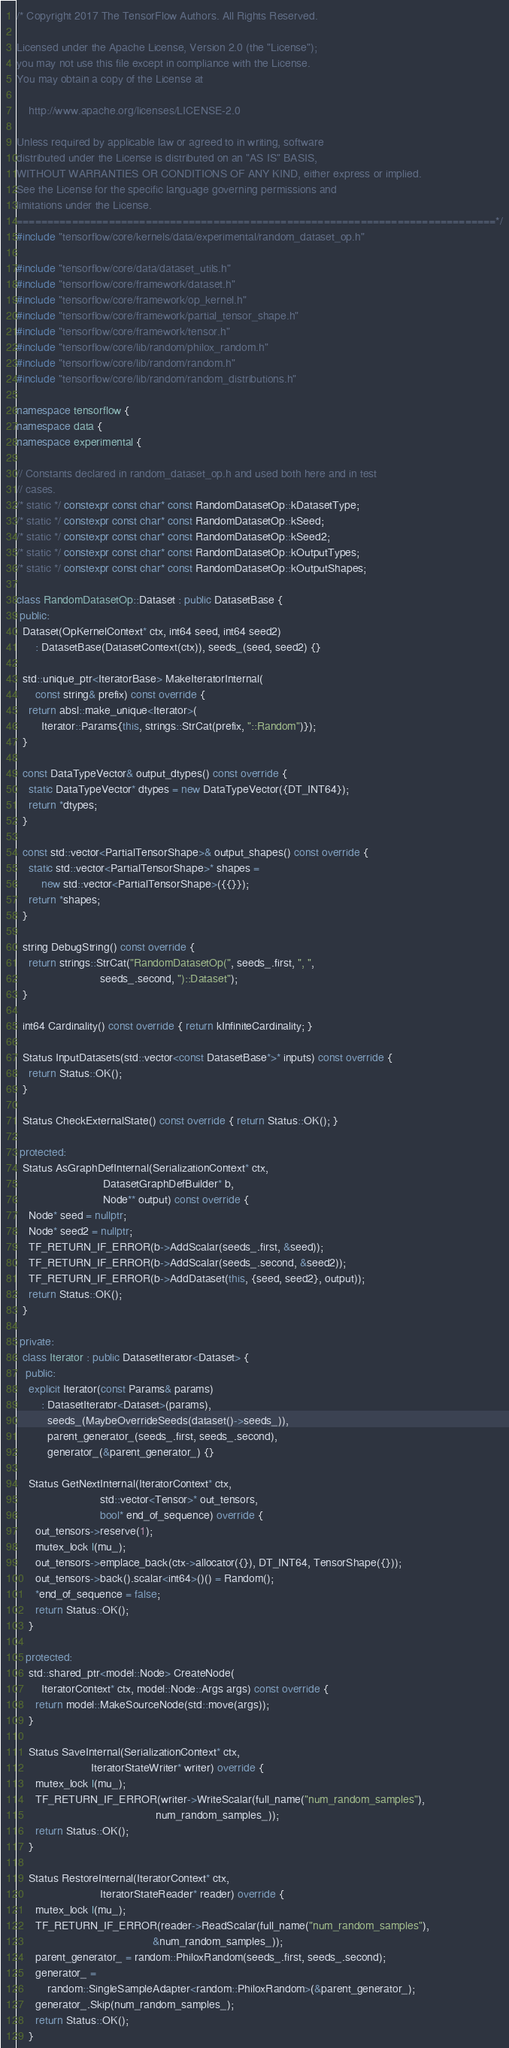Convert code to text. <code><loc_0><loc_0><loc_500><loc_500><_C++_>/* Copyright 2017 The TensorFlow Authors. All Rights Reserved.

Licensed under the Apache License, Version 2.0 (the "License");
you may not use this file except in compliance with the License.
You may obtain a copy of the License at

    http://www.apache.org/licenses/LICENSE-2.0

Unless required by applicable law or agreed to in writing, software
distributed under the License is distributed on an "AS IS" BASIS,
WITHOUT WARRANTIES OR CONDITIONS OF ANY KIND, either express or implied.
See the License for the specific language governing permissions and
limitations under the License.
==============================================================================*/
#include "tensorflow/core/kernels/data/experimental/random_dataset_op.h"

#include "tensorflow/core/data/dataset_utils.h"
#include "tensorflow/core/framework/dataset.h"
#include "tensorflow/core/framework/op_kernel.h"
#include "tensorflow/core/framework/partial_tensor_shape.h"
#include "tensorflow/core/framework/tensor.h"
#include "tensorflow/core/lib/random/philox_random.h"
#include "tensorflow/core/lib/random/random.h"
#include "tensorflow/core/lib/random/random_distributions.h"

namespace tensorflow {
namespace data {
namespace experimental {

// Constants declared in random_dataset_op.h and used both here and in test
// cases.
/* static */ constexpr const char* const RandomDatasetOp::kDatasetType;
/* static */ constexpr const char* const RandomDatasetOp::kSeed;
/* static */ constexpr const char* const RandomDatasetOp::kSeed2;
/* static */ constexpr const char* const RandomDatasetOp::kOutputTypes;
/* static */ constexpr const char* const RandomDatasetOp::kOutputShapes;

class RandomDatasetOp::Dataset : public DatasetBase {
 public:
  Dataset(OpKernelContext* ctx, int64 seed, int64 seed2)
      : DatasetBase(DatasetContext(ctx)), seeds_(seed, seed2) {}

  std::unique_ptr<IteratorBase> MakeIteratorInternal(
      const string& prefix) const override {
    return absl::make_unique<Iterator>(
        Iterator::Params{this, strings::StrCat(prefix, "::Random")});
  }

  const DataTypeVector& output_dtypes() const override {
    static DataTypeVector* dtypes = new DataTypeVector({DT_INT64});
    return *dtypes;
  }

  const std::vector<PartialTensorShape>& output_shapes() const override {
    static std::vector<PartialTensorShape>* shapes =
        new std::vector<PartialTensorShape>({{}});
    return *shapes;
  }

  string DebugString() const override {
    return strings::StrCat("RandomDatasetOp(", seeds_.first, ", ",
                           seeds_.second, ")::Dataset");
  }

  int64 Cardinality() const override { return kInfiniteCardinality; }

  Status InputDatasets(std::vector<const DatasetBase*>* inputs) const override {
    return Status::OK();
  }

  Status CheckExternalState() const override { return Status::OK(); }

 protected:
  Status AsGraphDefInternal(SerializationContext* ctx,
                            DatasetGraphDefBuilder* b,
                            Node** output) const override {
    Node* seed = nullptr;
    Node* seed2 = nullptr;
    TF_RETURN_IF_ERROR(b->AddScalar(seeds_.first, &seed));
    TF_RETURN_IF_ERROR(b->AddScalar(seeds_.second, &seed2));
    TF_RETURN_IF_ERROR(b->AddDataset(this, {seed, seed2}, output));
    return Status::OK();
  }

 private:
  class Iterator : public DatasetIterator<Dataset> {
   public:
    explicit Iterator(const Params& params)
        : DatasetIterator<Dataset>(params),
          seeds_(MaybeOverrideSeeds(dataset()->seeds_)),
          parent_generator_(seeds_.first, seeds_.second),
          generator_(&parent_generator_) {}

    Status GetNextInternal(IteratorContext* ctx,
                           std::vector<Tensor>* out_tensors,
                           bool* end_of_sequence) override {
      out_tensors->reserve(1);
      mutex_lock l(mu_);
      out_tensors->emplace_back(ctx->allocator({}), DT_INT64, TensorShape({}));
      out_tensors->back().scalar<int64>()() = Random();
      *end_of_sequence = false;
      return Status::OK();
    }

   protected:
    std::shared_ptr<model::Node> CreateNode(
        IteratorContext* ctx, model::Node::Args args) const override {
      return model::MakeSourceNode(std::move(args));
    }

    Status SaveInternal(SerializationContext* ctx,
                        IteratorStateWriter* writer) override {
      mutex_lock l(mu_);
      TF_RETURN_IF_ERROR(writer->WriteScalar(full_name("num_random_samples"),
                                             num_random_samples_));
      return Status::OK();
    }

    Status RestoreInternal(IteratorContext* ctx,
                           IteratorStateReader* reader) override {
      mutex_lock l(mu_);
      TF_RETURN_IF_ERROR(reader->ReadScalar(full_name("num_random_samples"),
                                            &num_random_samples_));
      parent_generator_ = random::PhiloxRandom(seeds_.first, seeds_.second);
      generator_ =
          random::SingleSampleAdapter<random::PhiloxRandom>(&parent_generator_);
      generator_.Skip(num_random_samples_);
      return Status::OK();
    }
</code> 